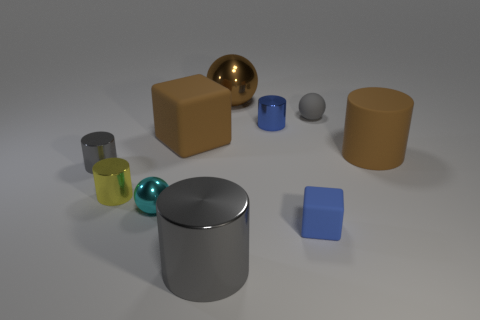Subtract 1 cylinders. How many cylinders are left? 4 Subtract all gray balls. Subtract all green blocks. How many balls are left? 2 Subtract all spheres. How many objects are left? 7 Add 6 large brown rubber things. How many large brown rubber things are left? 8 Add 8 big metal balls. How many big metal balls exist? 9 Subtract 0 purple cubes. How many objects are left? 10 Subtract all blue objects. Subtract all small blue shiny objects. How many objects are left? 7 